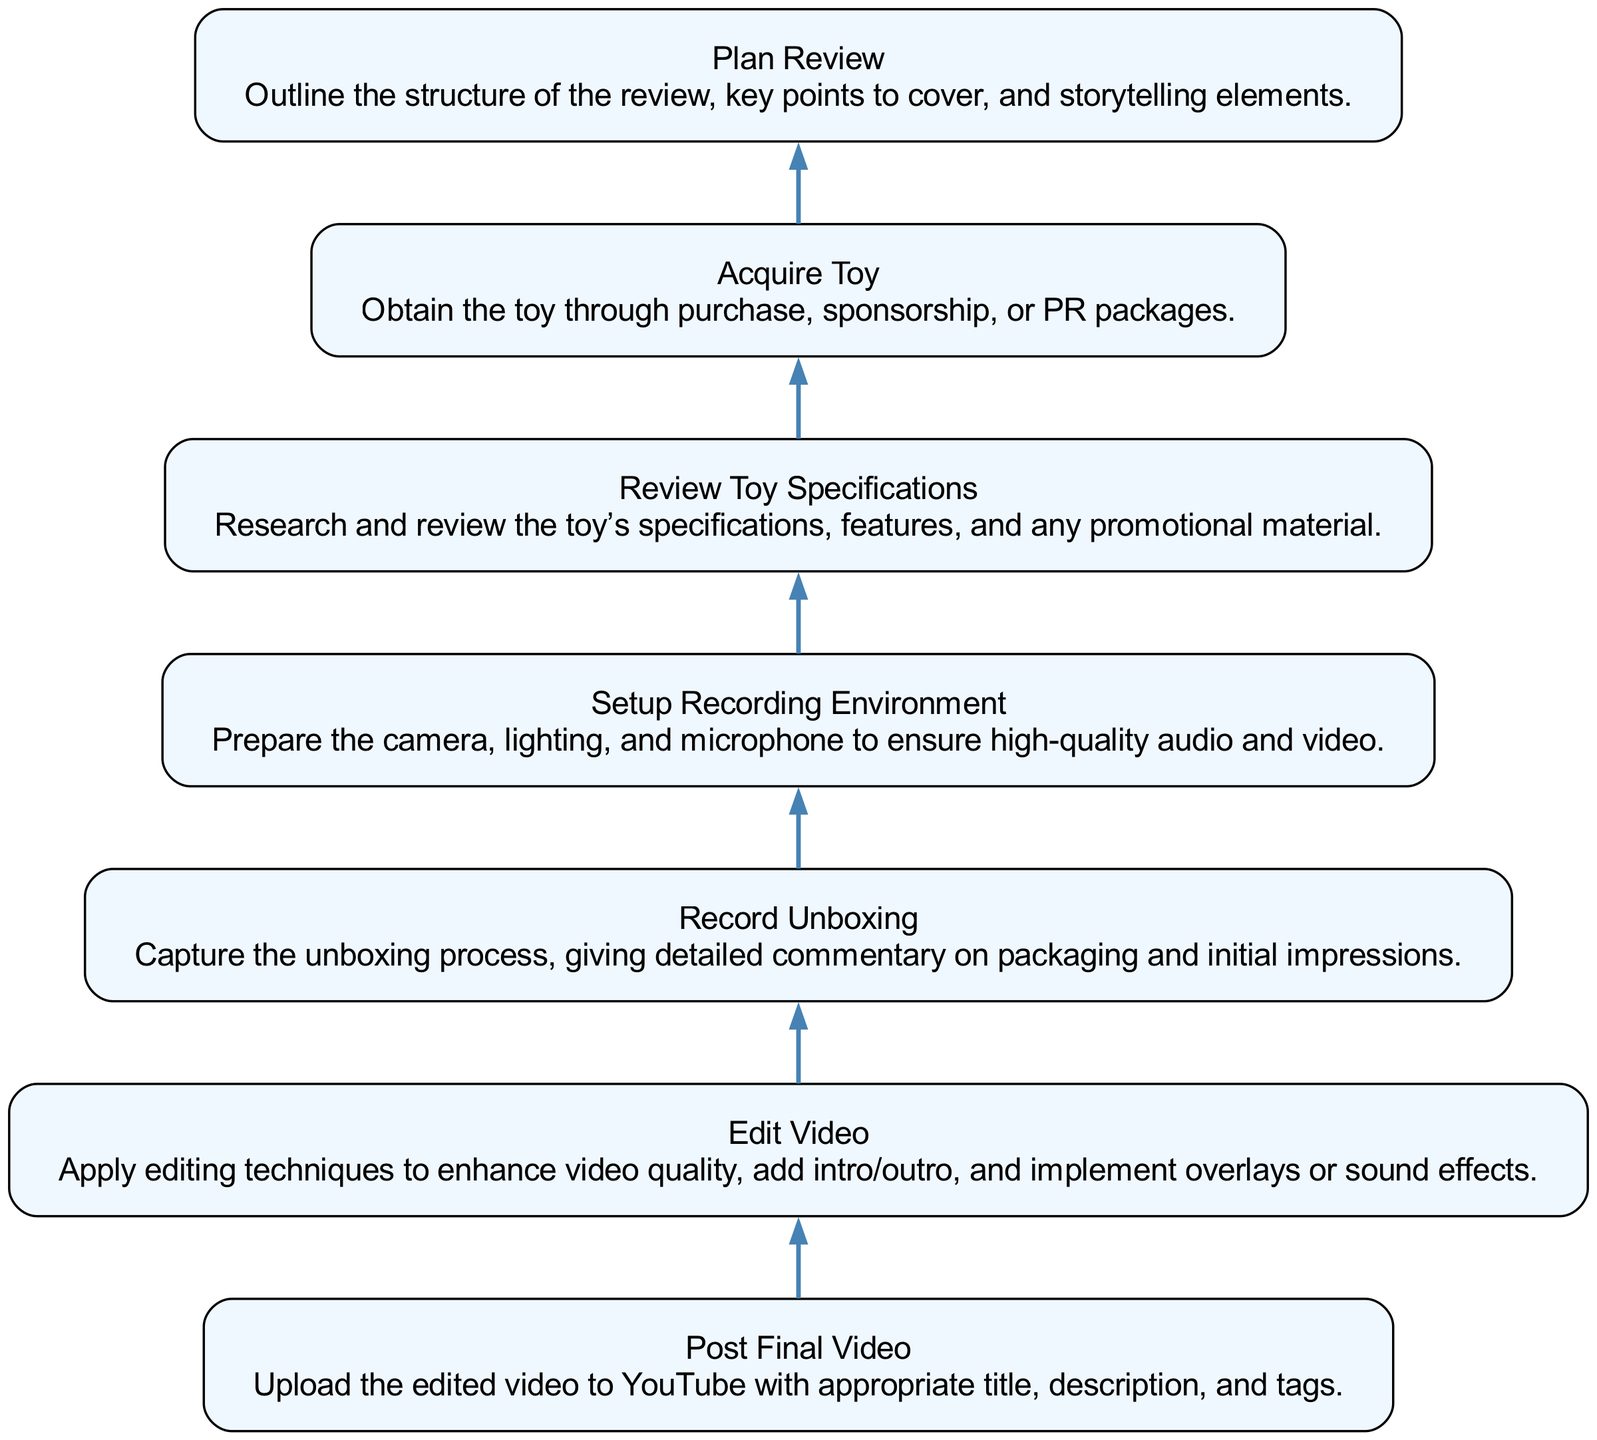What is the first step in the Toy Unboxing Process? The first step, as indicated at the bottom of the flowchart, is "Acquire Toy." This sets the foundation for the entire unboxing process.
Answer: Acquire Toy How many steps are there in total in the diagram? By counting each node in the diagram, we find there are seven steps included in the Toy Unboxing Process.
Answer: Seven What follows "Setup Recording Environment"? The diagram shows that "Setup Recording Environment" is followed by "Record Unboxing," indicating the progression from preparing to capturing the unboxing.
Answer: Record Unboxing What is the last step in the process? At the top of the diagram, the final step listed is "Post Final Video," marking the conclusion of the whole unboxing and review process.
Answer: Post Final Video Which step includes detailed commentary? The "Record Unboxing" step specifically mentions capturing the commentary on packaging and initial impressions, highlighting its importance in the review.
Answer: Record Unboxing What two steps are directly connected in sequence after "Review Toy Specifications"? Following "Review Toy Specifications," the next steps in sequence are "Plan Review" and then "Acquire Toy," showing the flow from understanding the toy to planning the review process.
Answer: Plan Review, Acquire Toy Which step relates to enhancing video quality? The process of "Edit Video" is all about enhancing video quality, applying techniques like overlays and sound effects to improve the final output.
Answer: Edit Video What do you do after "Plan Review"? After completing "Plan Review," the next step you take is "Acquire Toy," indicating that planning precedes obtaining the toy for review.
Answer: Acquire Toy How are "Edit Video" and "Post Final Video" connected? "Edit Video" is conducted before "Post Final Video," meaning that the video must be edited first and finalized before it's uploaded to YouTube.
Answer: Edit Video 